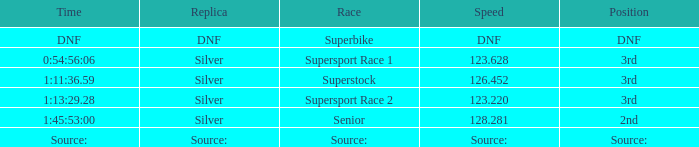Which race has a replica of DNF? Superbike. 